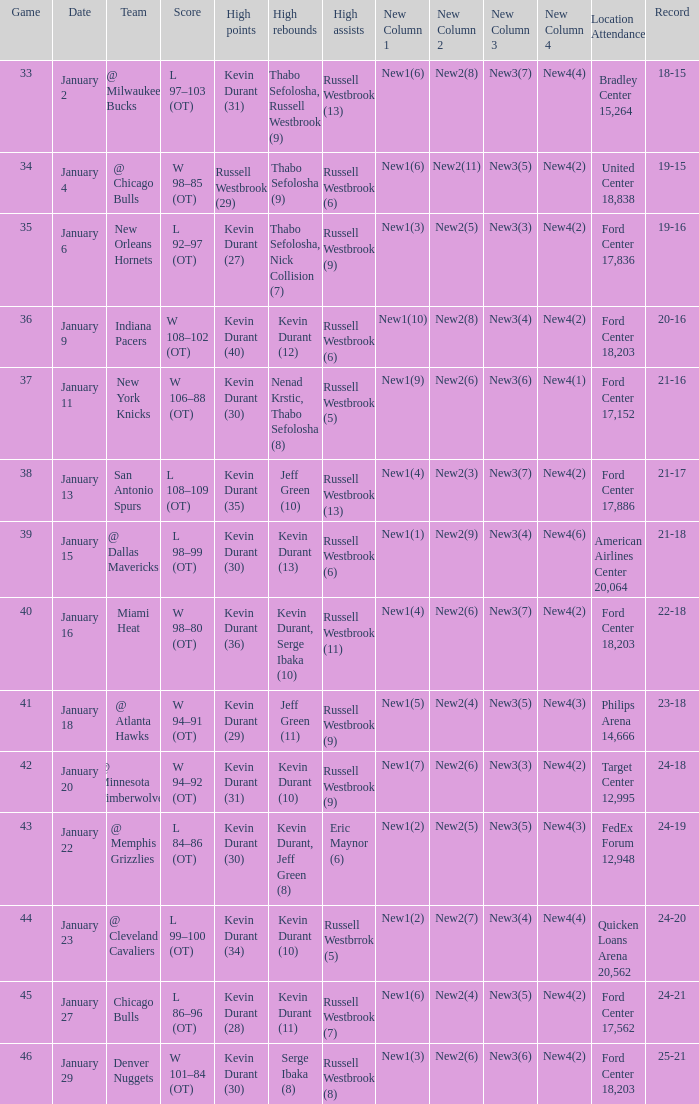Name the team for january 4 @ Chicago Bulls. 